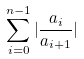Convert formula to latex. <formula><loc_0><loc_0><loc_500><loc_500>\sum _ { i = 0 } ^ { n - 1 } | \frac { a _ { i } } { a _ { i + 1 } } |</formula> 